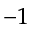Convert formula to latex. <formula><loc_0><loc_0><loc_500><loc_500>^ { - 1 }</formula> 